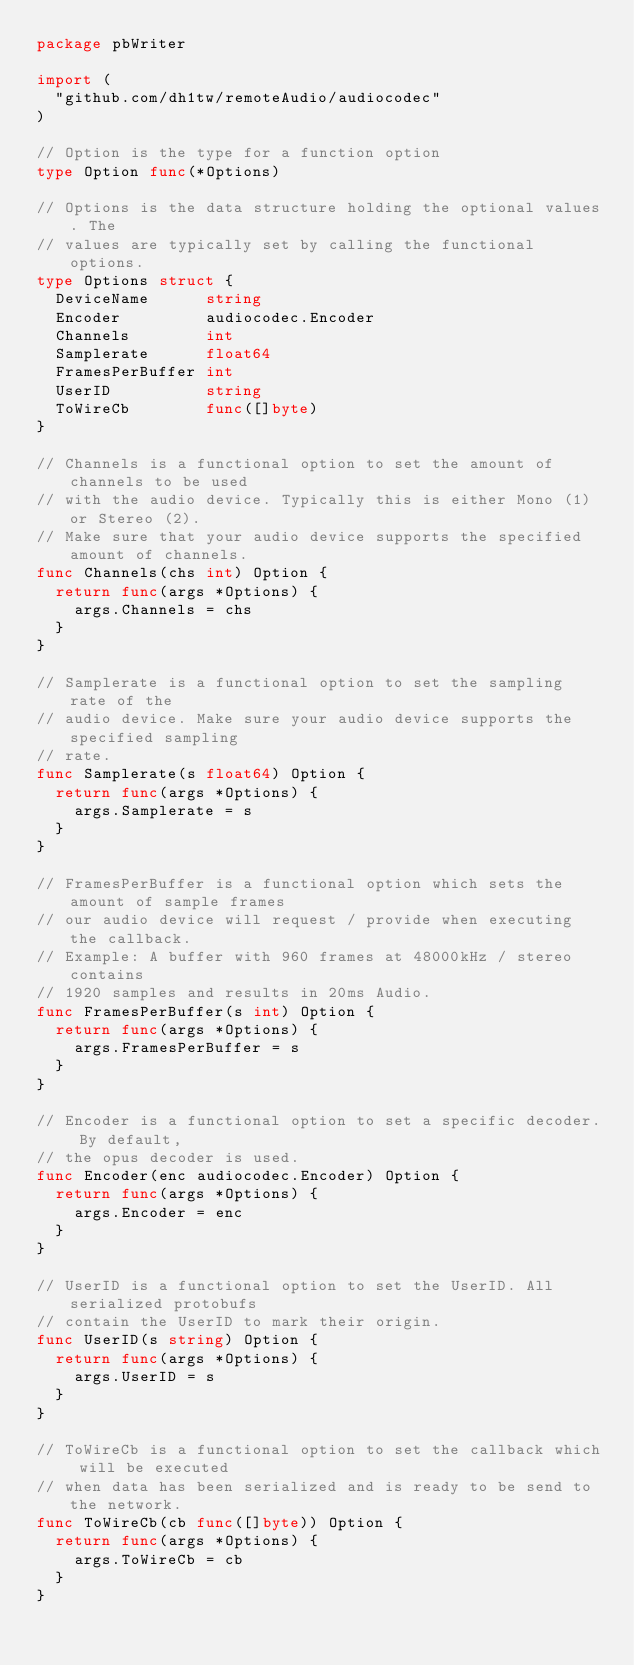Convert code to text. <code><loc_0><loc_0><loc_500><loc_500><_Go_>package pbWriter

import (
	"github.com/dh1tw/remoteAudio/audiocodec"
)

// Option is the type for a function option
type Option func(*Options)

// Options is the data structure holding the optional values. The
// values are typically set by calling the functional options.
type Options struct {
	DeviceName      string
	Encoder         audiocodec.Encoder
	Channels        int
	Samplerate      float64
	FramesPerBuffer int
	UserID          string
	ToWireCb        func([]byte)
}

// Channels is a functional option to set the amount of channels to be used
// with the audio device. Typically this is either Mono (1) or Stereo (2).
// Make sure that your audio device supports the specified amount of channels.
func Channels(chs int) Option {
	return func(args *Options) {
		args.Channels = chs
	}
}

// Samplerate is a functional option to set the sampling rate of the
// audio device. Make sure your audio device supports the specified sampling
// rate.
func Samplerate(s float64) Option {
	return func(args *Options) {
		args.Samplerate = s
	}
}

// FramesPerBuffer is a functional option which sets the amount of sample frames
// our audio device will request / provide when executing the callback.
// Example: A buffer with 960 frames at 48000kHz / stereo contains
// 1920 samples and results in 20ms Audio.
func FramesPerBuffer(s int) Option {
	return func(args *Options) {
		args.FramesPerBuffer = s
	}
}

// Encoder is a functional option to set a specific decoder. By default,
// the opus decoder is used.
func Encoder(enc audiocodec.Encoder) Option {
	return func(args *Options) {
		args.Encoder = enc
	}
}

// UserID is a functional option to set the UserID. All serialized protobufs
// contain the UserID to mark their origin.
func UserID(s string) Option {
	return func(args *Options) {
		args.UserID = s
	}
}

// ToWireCb is a functional option to set the callback which will be executed
// when data has been serialized and is ready to be send to the network.
func ToWireCb(cb func([]byte)) Option {
	return func(args *Options) {
		args.ToWireCb = cb
	}
}
</code> 